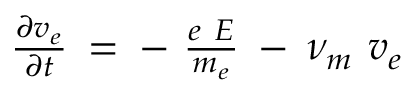<formula> <loc_0><loc_0><loc_500><loc_500>\begin{array} { r } { \frac { \partial v _ { e } } { \partial t } \, = \, - \ \frac { e \ E } { m _ { e } } \, - \, \nu _ { m } \ v _ { e } } \end{array}</formula> 